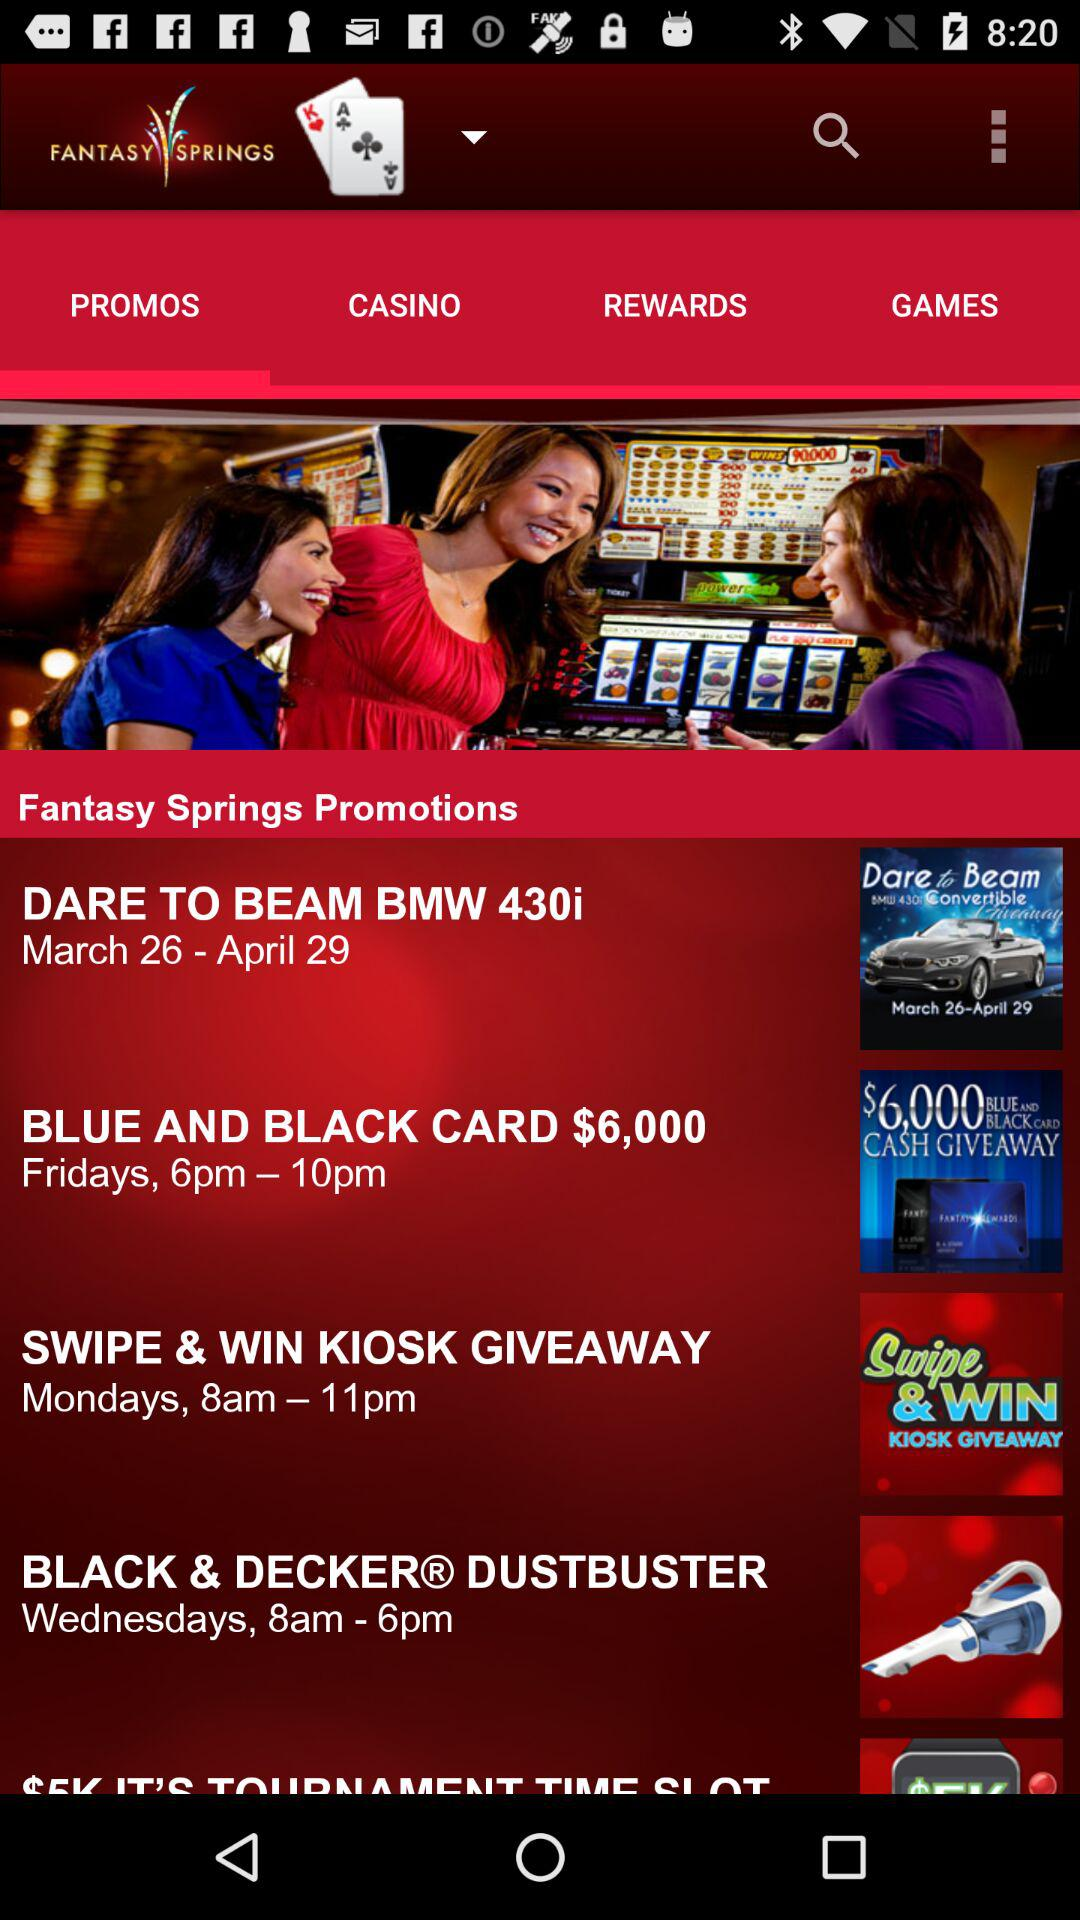What is the application name? The application name is "FANTASY SPRINGS". 